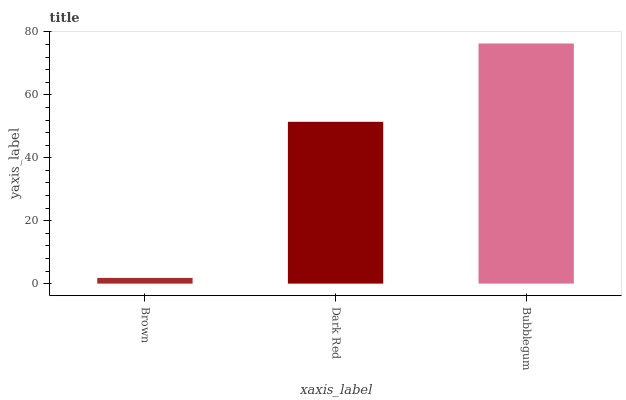Is Brown the minimum?
Answer yes or no. Yes. Is Bubblegum the maximum?
Answer yes or no. Yes. Is Dark Red the minimum?
Answer yes or no. No. Is Dark Red the maximum?
Answer yes or no. No. Is Dark Red greater than Brown?
Answer yes or no. Yes. Is Brown less than Dark Red?
Answer yes or no. Yes. Is Brown greater than Dark Red?
Answer yes or no. No. Is Dark Red less than Brown?
Answer yes or no. No. Is Dark Red the high median?
Answer yes or no. Yes. Is Dark Red the low median?
Answer yes or no. Yes. Is Brown the high median?
Answer yes or no. No. Is Brown the low median?
Answer yes or no. No. 